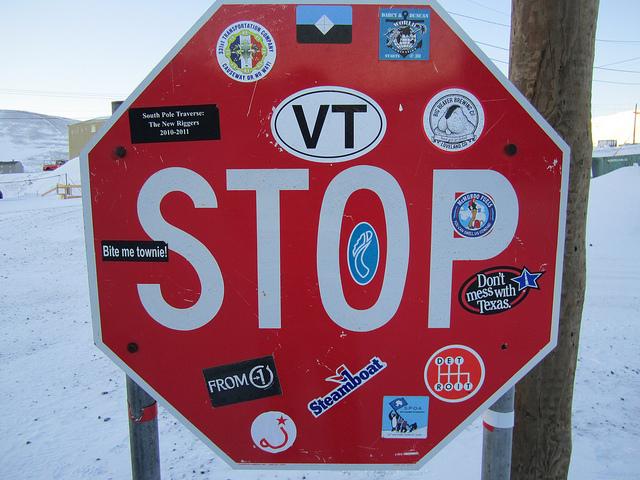What kind of sign is this?
Write a very short answer. Stop. Are the stickers on the stop sign considered graffiti?
Give a very brief answer. Yes. Is this a normal stop sign?
Answer briefly. No. 